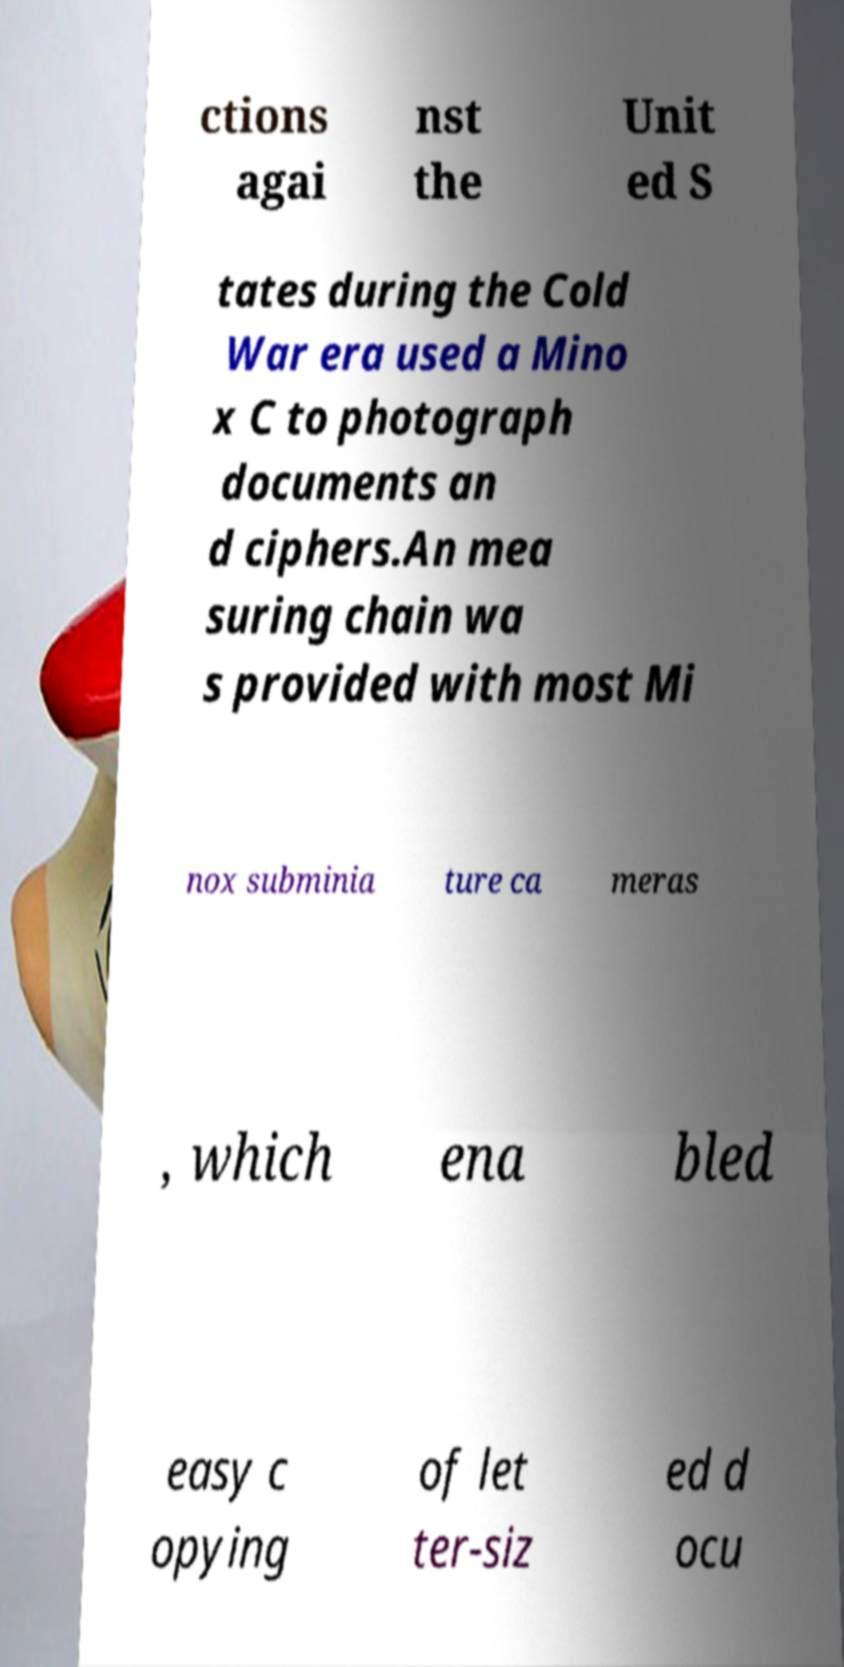Please identify and transcribe the text found in this image. ctions agai nst the Unit ed S tates during the Cold War era used a Mino x C to photograph documents an d ciphers.An mea suring chain wa s provided with most Mi nox subminia ture ca meras , which ena bled easy c opying of let ter-siz ed d ocu 